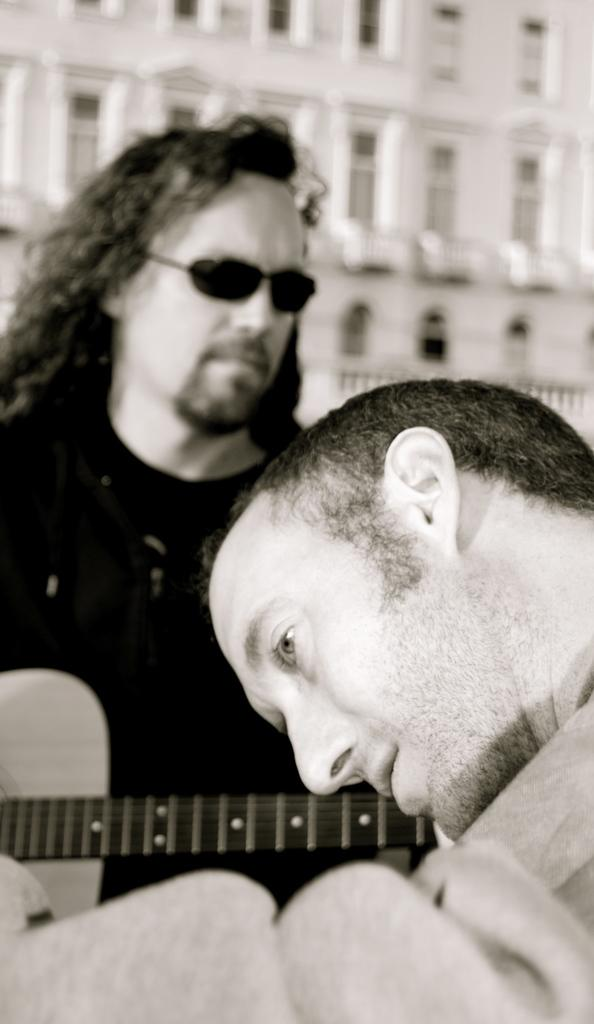How many people are in the image? There are two persons in the image. What is one of the persons holding? One person is holding a guitar. What can be seen in the background of the image? There is a building in the background of the image. How many cherries are on the guitar in the image? There are no cherries present on the guitar in the image. What is the weight of the building in the background? The weight of the building cannot be determined from the image alone. 